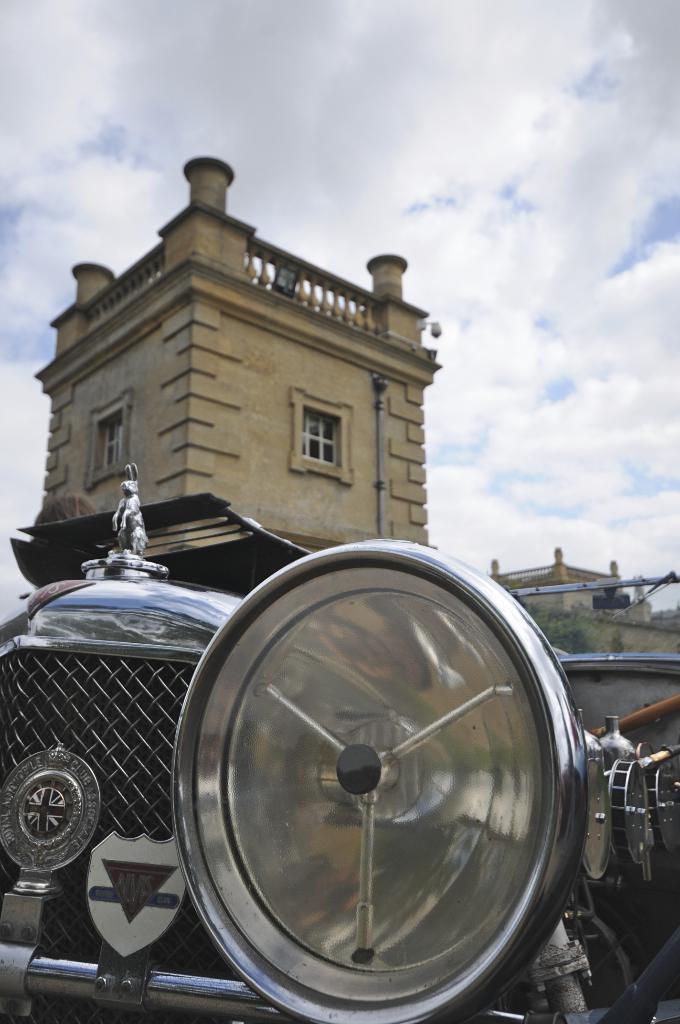Could you give a brief overview of what you see in this image? In this image we can see a car. On the backside we can see some buildings with windows. We can also see some trees and the sky which looks cloudy. 